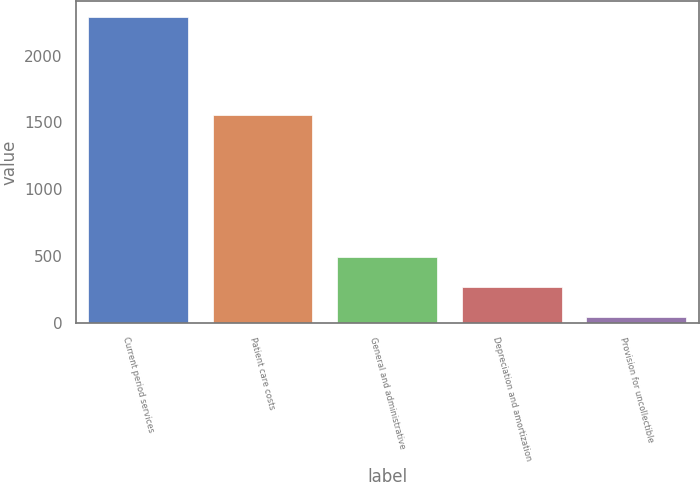<chart> <loc_0><loc_0><loc_500><loc_500><bar_chart><fcel>Current period services<fcel>Patient care costs<fcel>General and administrative<fcel>Depreciation and amortization<fcel>Provision for uncollectible<nl><fcel>2291<fcel>1555<fcel>491<fcel>266<fcel>41<nl></chart> 